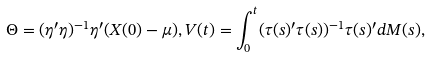Convert formula to latex. <formula><loc_0><loc_0><loc_500><loc_500>\Theta = ( \eta ^ { \prime } \eta ) ^ { - 1 } \eta ^ { \prime } ( X ( 0 ) - \mu ) , V ( t ) = \int _ { 0 } ^ { t } ( \tau ( s ) ^ { \prime } \tau ( s ) ) ^ { - 1 } \tau ( s ) ^ { \prime } d M ( s ) ,</formula> 